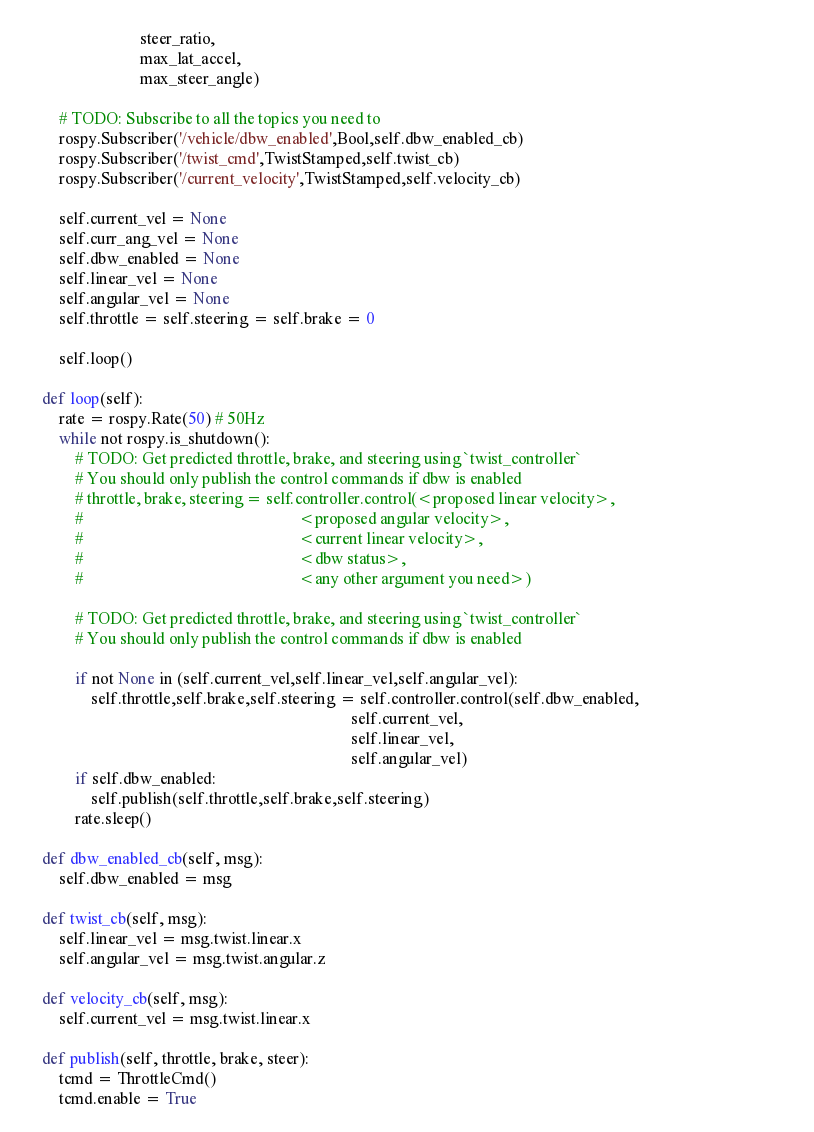<code> <loc_0><loc_0><loc_500><loc_500><_Python_>                            steer_ratio,
                            max_lat_accel,
                            max_steer_angle)
        
        # TODO: Subscribe to all the topics you need to
        rospy.Subscriber('/vehicle/dbw_enabled',Bool,self.dbw_enabled_cb)
        rospy.Subscriber('/twist_cmd',TwistStamped,self.twist_cb)
        rospy.Subscriber('/current_velocity',TwistStamped,self.velocity_cb)
        
        self.current_vel = None
        self.curr_ang_vel = None
        self.dbw_enabled = None
        self.linear_vel = None
        self.angular_vel = None
        self.throttle = self.steering = self.brake = 0

        self.loop()

    def loop(self):
        rate = rospy.Rate(50) # 50Hz
        while not rospy.is_shutdown():
            # TODO: Get predicted throttle, brake, and steering using `twist_controller`
            # You should only publish the control commands if dbw is enabled
            # throttle, brake, steering = self.controller.control(<proposed linear velocity>,
            #                                                     <proposed angular velocity>,
            #                                                     <current linear velocity>,
            #                                                     <dbw status>,
            #                                                     <any other argument you need>)
        
            # TODO: Get predicted throttle, brake, and steering using `twist_controller`
            # You should only publish the control commands if dbw is enabled
            
            if not None in (self.current_vel,self.linear_vel,self.angular_vel):
                self.throttle,self.brake,self.steering = self.controller.control(self.dbw_enabled, 
                                                                                self.current_vel,                                                                                
                                                                                self.linear_vel,
                                                                                self.angular_vel)
            if self.dbw_enabled:
                self.publish(self.throttle,self.brake,self.steering)           
            rate.sleep()
    
    def dbw_enabled_cb(self, msg):
        self.dbw_enabled = msg
        
    def twist_cb(self, msg):
        self.linear_vel = msg.twist.linear.x
        self.angular_vel = msg.twist.angular.z
        
    def velocity_cb(self, msg):
        self.current_vel = msg.twist.linear.x
    
    def publish(self, throttle, brake, steer):
        tcmd = ThrottleCmd()
        tcmd.enable = True</code> 